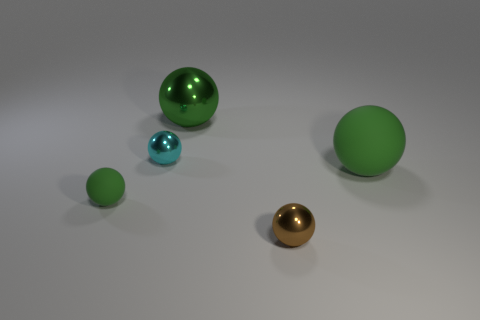What number of tiny things are either cyan things or green matte spheres?
Offer a very short reply. 2. Are there the same number of small cyan spheres that are right of the big green shiny sphere and tiny green balls left of the small brown metallic thing?
Your answer should be compact. No. How many other objects are there of the same color as the tiny matte object?
Ensure brevity in your answer.  2. There is a large matte object; is it the same color as the big metallic sphere right of the small cyan thing?
Make the answer very short. Yes. What number of cyan objects are either spheres or tiny things?
Your response must be concise. 1. Are there an equal number of tiny green balls that are to the right of the tiny matte sphere and yellow matte blocks?
Your answer should be compact. Yes. The other big thing that is the same shape as the big matte object is what color?
Keep it short and to the point. Green. How many tiny green rubber objects have the same shape as the cyan object?
Make the answer very short. 1. There is a large ball that is the same color as the big matte object; what material is it?
Offer a terse response. Metal. What number of big matte spheres are there?
Provide a succinct answer. 1. 